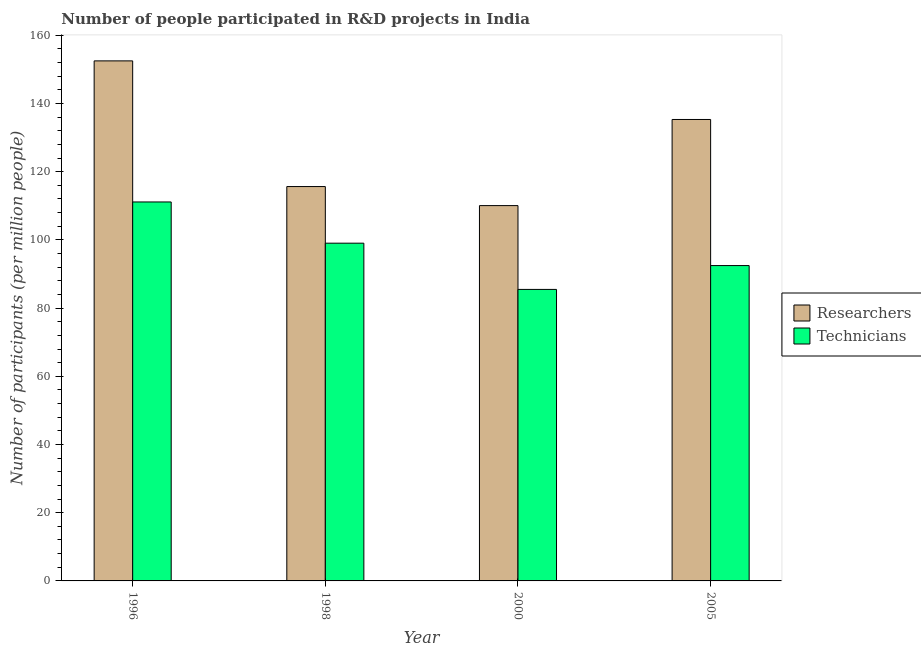How many different coloured bars are there?
Give a very brief answer. 2. Are the number of bars per tick equal to the number of legend labels?
Your answer should be compact. Yes. Are the number of bars on each tick of the X-axis equal?
Keep it short and to the point. Yes. How many bars are there on the 3rd tick from the left?
Offer a terse response. 2. What is the label of the 2nd group of bars from the left?
Give a very brief answer. 1998. What is the number of technicians in 2005?
Your response must be concise. 92.46. Across all years, what is the maximum number of researchers?
Make the answer very short. 152.48. Across all years, what is the minimum number of technicians?
Your response must be concise. 85.47. What is the total number of technicians in the graph?
Give a very brief answer. 388.09. What is the difference between the number of researchers in 1998 and that in 2000?
Your answer should be very brief. 5.58. What is the difference between the number of technicians in 2000 and the number of researchers in 1998?
Keep it short and to the point. -13.56. What is the average number of technicians per year?
Your answer should be compact. 97.02. In how many years, is the number of technicians greater than 64?
Offer a terse response. 4. What is the ratio of the number of researchers in 1996 to that in 1998?
Provide a short and direct response. 1.32. Is the number of researchers in 1996 less than that in 2000?
Your answer should be very brief. No. What is the difference between the highest and the second highest number of technicians?
Offer a very short reply. 12.09. What is the difference between the highest and the lowest number of technicians?
Offer a terse response. 25.64. Is the sum of the number of technicians in 1996 and 2005 greater than the maximum number of researchers across all years?
Give a very brief answer. Yes. What does the 2nd bar from the left in 2000 represents?
Provide a short and direct response. Technicians. What does the 2nd bar from the right in 1998 represents?
Make the answer very short. Researchers. How many bars are there?
Your response must be concise. 8. Are all the bars in the graph horizontal?
Make the answer very short. No. Where does the legend appear in the graph?
Provide a short and direct response. Center right. How are the legend labels stacked?
Keep it short and to the point. Vertical. What is the title of the graph?
Provide a short and direct response. Number of people participated in R&D projects in India. Does "Banks" appear as one of the legend labels in the graph?
Your answer should be compact. No. What is the label or title of the Y-axis?
Provide a short and direct response. Number of participants (per million people). What is the Number of participants (per million people) in Researchers in 1996?
Offer a very short reply. 152.48. What is the Number of participants (per million people) in Technicians in 1996?
Provide a succinct answer. 111.12. What is the Number of participants (per million people) in Researchers in 1998?
Your response must be concise. 115.63. What is the Number of participants (per million people) of Technicians in 1998?
Give a very brief answer. 99.03. What is the Number of participants (per million people) in Researchers in 2000?
Your response must be concise. 110.05. What is the Number of participants (per million people) of Technicians in 2000?
Offer a very short reply. 85.47. What is the Number of participants (per million people) of Researchers in 2005?
Provide a succinct answer. 135.3. What is the Number of participants (per million people) in Technicians in 2005?
Provide a succinct answer. 92.46. Across all years, what is the maximum Number of participants (per million people) of Researchers?
Your answer should be compact. 152.48. Across all years, what is the maximum Number of participants (per million people) of Technicians?
Provide a short and direct response. 111.12. Across all years, what is the minimum Number of participants (per million people) of Researchers?
Offer a terse response. 110.05. Across all years, what is the minimum Number of participants (per million people) of Technicians?
Offer a very short reply. 85.47. What is the total Number of participants (per million people) of Researchers in the graph?
Offer a very short reply. 513.47. What is the total Number of participants (per million people) of Technicians in the graph?
Give a very brief answer. 388.09. What is the difference between the Number of participants (per million people) in Researchers in 1996 and that in 1998?
Offer a very short reply. 36.85. What is the difference between the Number of participants (per million people) of Technicians in 1996 and that in 1998?
Offer a terse response. 12.09. What is the difference between the Number of participants (per million people) of Researchers in 1996 and that in 2000?
Make the answer very short. 42.43. What is the difference between the Number of participants (per million people) of Technicians in 1996 and that in 2000?
Offer a very short reply. 25.64. What is the difference between the Number of participants (per million people) in Researchers in 1996 and that in 2005?
Provide a short and direct response. 17.18. What is the difference between the Number of participants (per million people) of Technicians in 1996 and that in 2005?
Your answer should be very brief. 18.66. What is the difference between the Number of participants (per million people) of Researchers in 1998 and that in 2000?
Your answer should be compact. 5.58. What is the difference between the Number of participants (per million people) of Technicians in 1998 and that in 2000?
Your answer should be compact. 13.56. What is the difference between the Number of participants (per million people) of Researchers in 1998 and that in 2005?
Offer a terse response. -19.67. What is the difference between the Number of participants (per million people) of Technicians in 1998 and that in 2005?
Offer a very short reply. 6.57. What is the difference between the Number of participants (per million people) of Researchers in 2000 and that in 2005?
Keep it short and to the point. -25.25. What is the difference between the Number of participants (per million people) of Technicians in 2000 and that in 2005?
Your answer should be very brief. -6.99. What is the difference between the Number of participants (per million people) in Researchers in 1996 and the Number of participants (per million people) in Technicians in 1998?
Your answer should be compact. 53.45. What is the difference between the Number of participants (per million people) of Researchers in 1996 and the Number of participants (per million people) of Technicians in 2000?
Your answer should be compact. 67.01. What is the difference between the Number of participants (per million people) of Researchers in 1996 and the Number of participants (per million people) of Technicians in 2005?
Ensure brevity in your answer.  60.02. What is the difference between the Number of participants (per million people) in Researchers in 1998 and the Number of participants (per million people) in Technicians in 2000?
Ensure brevity in your answer.  30.16. What is the difference between the Number of participants (per million people) of Researchers in 1998 and the Number of participants (per million people) of Technicians in 2005?
Give a very brief answer. 23.17. What is the difference between the Number of participants (per million people) in Researchers in 2000 and the Number of participants (per million people) in Technicians in 2005?
Keep it short and to the point. 17.59. What is the average Number of participants (per million people) in Researchers per year?
Make the answer very short. 128.37. What is the average Number of participants (per million people) of Technicians per year?
Give a very brief answer. 97.02. In the year 1996, what is the difference between the Number of participants (per million people) of Researchers and Number of participants (per million people) of Technicians?
Offer a terse response. 41.37. In the year 1998, what is the difference between the Number of participants (per million people) of Researchers and Number of participants (per million people) of Technicians?
Your answer should be very brief. 16.6. In the year 2000, what is the difference between the Number of participants (per million people) of Researchers and Number of participants (per million people) of Technicians?
Ensure brevity in your answer.  24.58. In the year 2005, what is the difference between the Number of participants (per million people) of Researchers and Number of participants (per million people) of Technicians?
Offer a very short reply. 42.84. What is the ratio of the Number of participants (per million people) of Researchers in 1996 to that in 1998?
Offer a terse response. 1.32. What is the ratio of the Number of participants (per million people) in Technicians in 1996 to that in 1998?
Ensure brevity in your answer.  1.12. What is the ratio of the Number of participants (per million people) of Researchers in 1996 to that in 2000?
Give a very brief answer. 1.39. What is the ratio of the Number of participants (per million people) in Technicians in 1996 to that in 2000?
Your answer should be very brief. 1.3. What is the ratio of the Number of participants (per million people) of Researchers in 1996 to that in 2005?
Offer a very short reply. 1.13. What is the ratio of the Number of participants (per million people) of Technicians in 1996 to that in 2005?
Keep it short and to the point. 1.2. What is the ratio of the Number of participants (per million people) of Researchers in 1998 to that in 2000?
Offer a very short reply. 1.05. What is the ratio of the Number of participants (per million people) in Technicians in 1998 to that in 2000?
Your answer should be compact. 1.16. What is the ratio of the Number of participants (per million people) of Researchers in 1998 to that in 2005?
Offer a terse response. 0.85. What is the ratio of the Number of participants (per million people) of Technicians in 1998 to that in 2005?
Ensure brevity in your answer.  1.07. What is the ratio of the Number of participants (per million people) in Researchers in 2000 to that in 2005?
Your response must be concise. 0.81. What is the ratio of the Number of participants (per million people) in Technicians in 2000 to that in 2005?
Your answer should be very brief. 0.92. What is the difference between the highest and the second highest Number of participants (per million people) of Researchers?
Offer a terse response. 17.18. What is the difference between the highest and the second highest Number of participants (per million people) of Technicians?
Provide a short and direct response. 12.09. What is the difference between the highest and the lowest Number of participants (per million people) of Researchers?
Your response must be concise. 42.43. What is the difference between the highest and the lowest Number of participants (per million people) in Technicians?
Your answer should be compact. 25.64. 